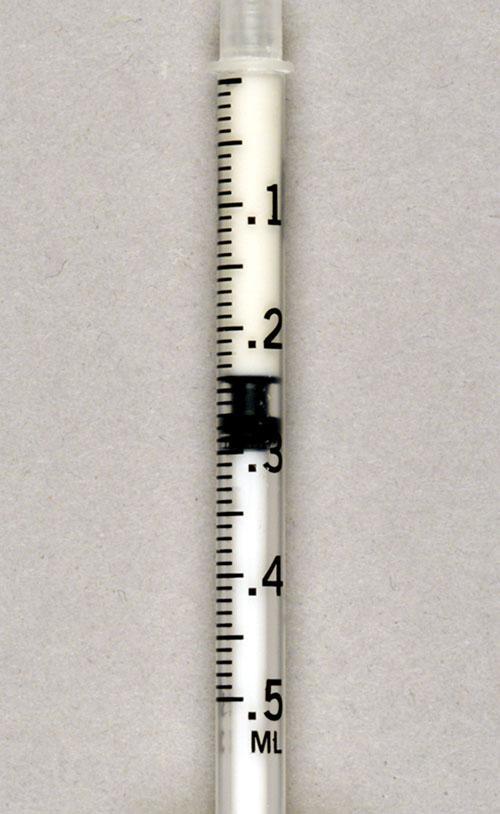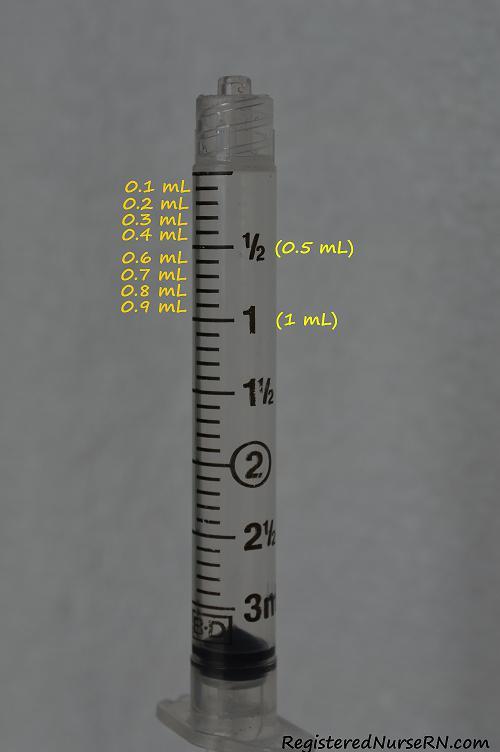The first image is the image on the left, the second image is the image on the right. For the images displayed, is the sentence "At least one photo contains a syringe with a green tip." factually correct? Answer yes or no. No. The first image is the image on the left, the second image is the image on the right. Analyze the images presented: Is the assertion "One of the syringes has a green tip." valid? Answer yes or no. No. 